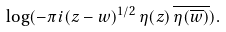Convert formula to latex. <formula><loc_0><loc_0><loc_500><loc_500>\log ( - \pi i ( z - w ) ^ { 1 / 2 } \, \eta ( z ) \, \overline { \eta ( \overline { w } ) } ) .</formula> 